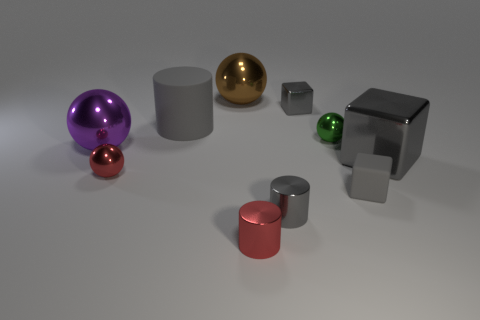What material do the objects in the image look like they're made of? The objects in the image seem to have a smooth, reflective surface, suggesting that they are made of materials like polished metal or glass, known for their reflective properties and sheen. 